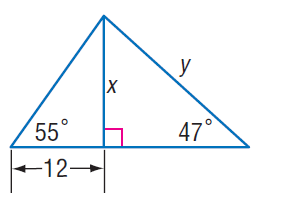Answer the mathemtical geometry problem and directly provide the correct option letter.
Question: Find x.
Choices: A: 17.1 B: 18.9 C: 21.2 D: 32.3 A 